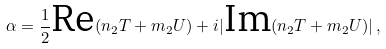<formula> <loc_0><loc_0><loc_500><loc_500>\alpha = \frac { 1 } { 2 } \text {Re} ( n _ { 2 } T + m _ { 2 } U ) + i | \text {Im} ( n _ { 2 } T + m _ { 2 } U ) | \, ,</formula> 